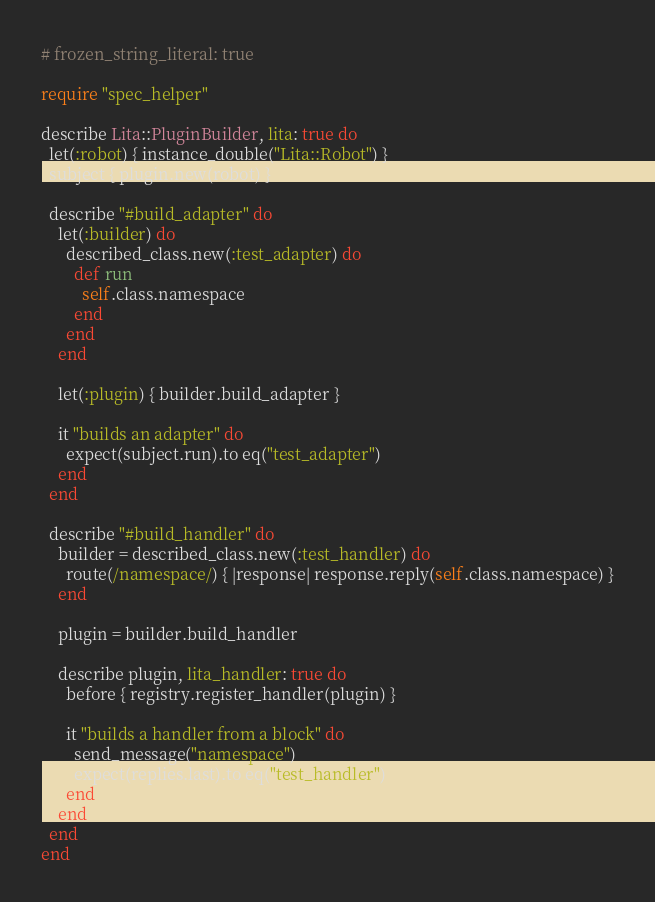Convert code to text. <code><loc_0><loc_0><loc_500><loc_500><_Ruby_># frozen_string_literal: true

require "spec_helper"

describe Lita::PluginBuilder, lita: true do
  let(:robot) { instance_double("Lita::Robot") }
  subject { plugin.new(robot) }

  describe "#build_adapter" do
    let(:builder) do
      described_class.new(:test_adapter) do
        def run
          self.class.namespace
        end
      end
    end

    let(:plugin) { builder.build_adapter }

    it "builds an adapter" do
      expect(subject.run).to eq("test_adapter")
    end
  end

  describe "#build_handler" do
    builder = described_class.new(:test_handler) do
      route(/namespace/) { |response| response.reply(self.class.namespace) }
    end

    plugin = builder.build_handler

    describe plugin, lita_handler: true do
      before { registry.register_handler(plugin) }

      it "builds a handler from a block" do
        send_message("namespace")
        expect(replies.last).to eq("test_handler")
      end
    end
  end
end
</code> 